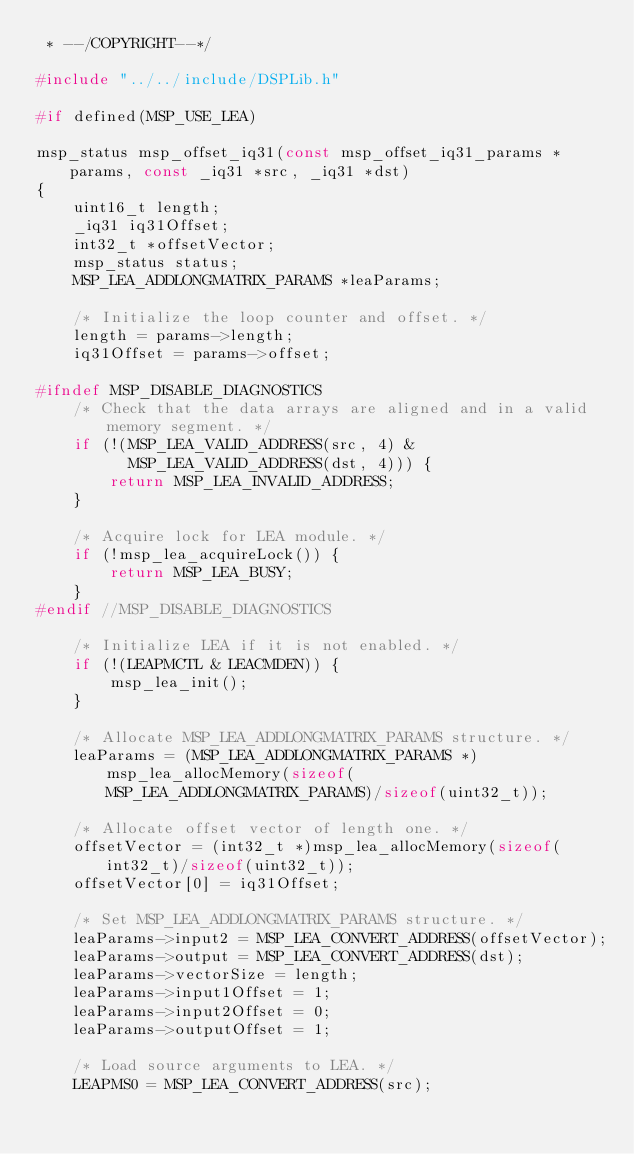Convert code to text. <code><loc_0><loc_0><loc_500><loc_500><_C_> * --/COPYRIGHT--*/

#include "../../include/DSPLib.h"

#if defined(MSP_USE_LEA)

msp_status msp_offset_iq31(const msp_offset_iq31_params *params, const _iq31 *src, _iq31 *dst)
{
    uint16_t length;
    _iq31 iq31Offset;
    int32_t *offsetVector;
    msp_status status;
    MSP_LEA_ADDLONGMATRIX_PARAMS *leaParams;
    
    /* Initialize the loop counter and offset. */
    length = params->length;
    iq31Offset = params->offset;

#ifndef MSP_DISABLE_DIAGNOSTICS
    /* Check that the data arrays are aligned and in a valid memory segment. */
    if (!(MSP_LEA_VALID_ADDRESS(src, 4) &
          MSP_LEA_VALID_ADDRESS(dst, 4))) {
        return MSP_LEA_INVALID_ADDRESS;
    }

    /* Acquire lock for LEA module. */
    if (!msp_lea_acquireLock()) {
        return MSP_LEA_BUSY;
    }
#endif //MSP_DISABLE_DIAGNOSTICS

    /* Initialize LEA if it is not enabled. */
    if (!(LEAPMCTL & LEACMDEN)) {
        msp_lea_init();
    }
        
    /* Allocate MSP_LEA_ADDLONGMATRIX_PARAMS structure. */
    leaParams = (MSP_LEA_ADDLONGMATRIX_PARAMS *)msp_lea_allocMemory(sizeof(MSP_LEA_ADDLONGMATRIX_PARAMS)/sizeof(uint32_t));
        
    /* Allocate offset vector of length one. */
    offsetVector = (int32_t *)msp_lea_allocMemory(sizeof(int32_t)/sizeof(uint32_t));
    offsetVector[0] = iq31Offset;

    /* Set MSP_LEA_ADDLONGMATRIX_PARAMS structure. */
    leaParams->input2 = MSP_LEA_CONVERT_ADDRESS(offsetVector);
    leaParams->output = MSP_LEA_CONVERT_ADDRESS(dst);
    leaParams->vectorSize = length;
    leaParams->input1Offset = 1;
    leaParams->input2Offset = 0;
    leaParams->outputOffset = 1;

    /* Load source arguments to LEA. */
    LEAPMS0 = MSP_LEA_CONVERT_ADDRESS(src);</code> 